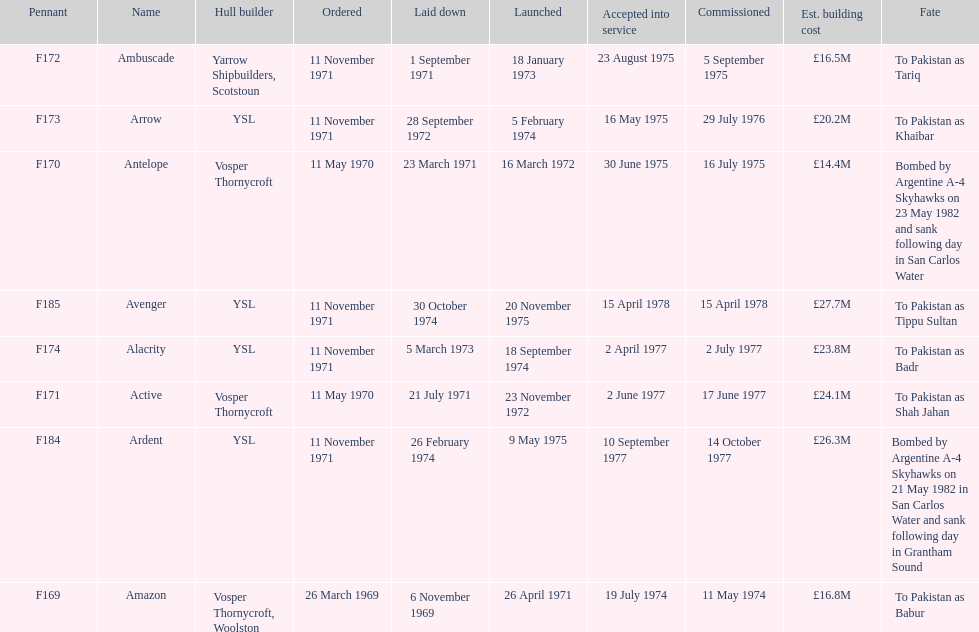What is the last name listed on this chart? Avenger. 